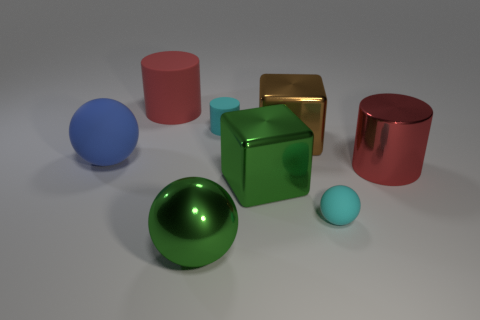The big sphere in front of the big shiny cylinder is what color? The large sphere located prominently in the foreground, just ahead of the shiny, reflective cylinder, exhibits a vibrant green hue. 